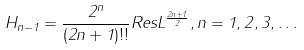<formula> <loc_0><loc_0><loc_500><loc_500>H _ { n - 1 } = \frac { 2 ^ { n } } { ( 2 n + 1 ) ! ! } R e s L ^ { \frac { 2 n + 1 } { 2 } } , n = 1 , 2 , 3 , \dots</formula> 